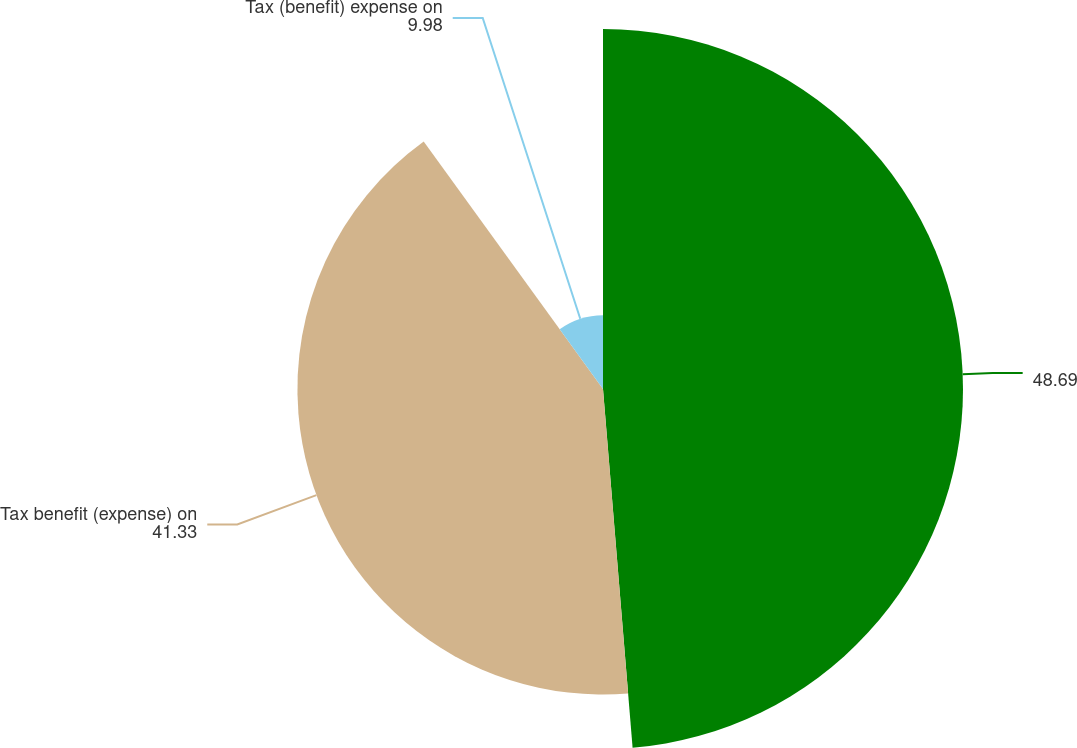Convert chart to OTSL. <chart><loc_0><loc_0><loc_500><loc_500><pie_chart><ecel><fcel>Tax benefit (expense) on<fcel>Tax (benefit) expense on<nl><fcel>48.69%<fcel>41.33%<fcel>9.98%<nl></chart> 